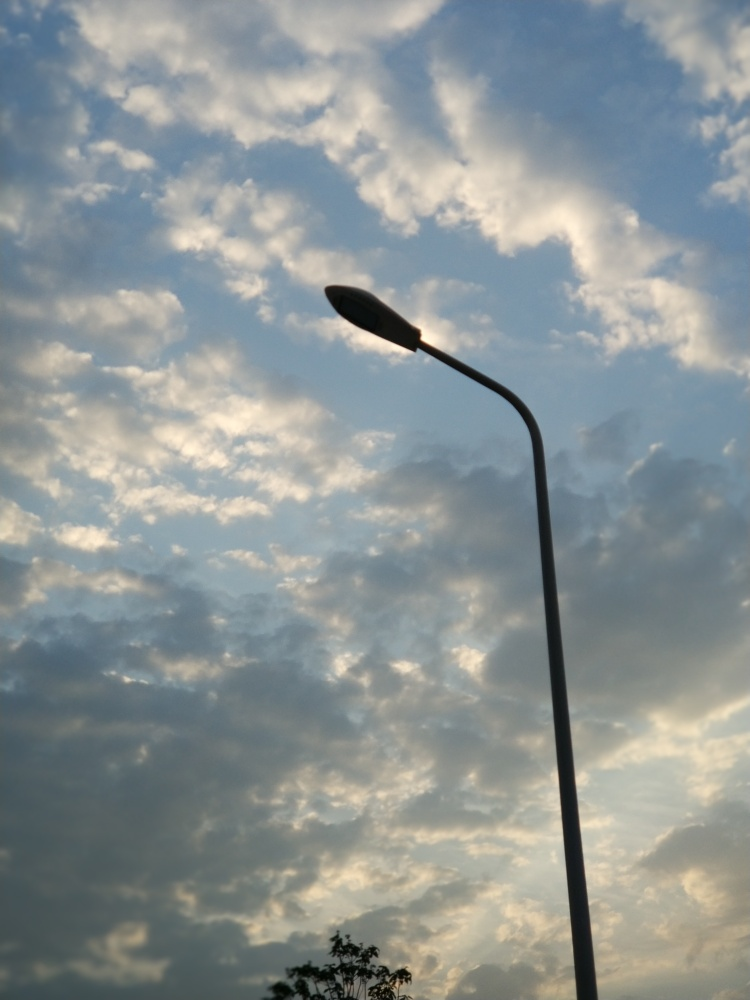What time of day does this image suggest, and why? The image suggests it's either early morning or late afternoon, as indicated by the warm tones spreading across the clouds and the way they are softly lit from one side, implying the sun is low on the horizon. 